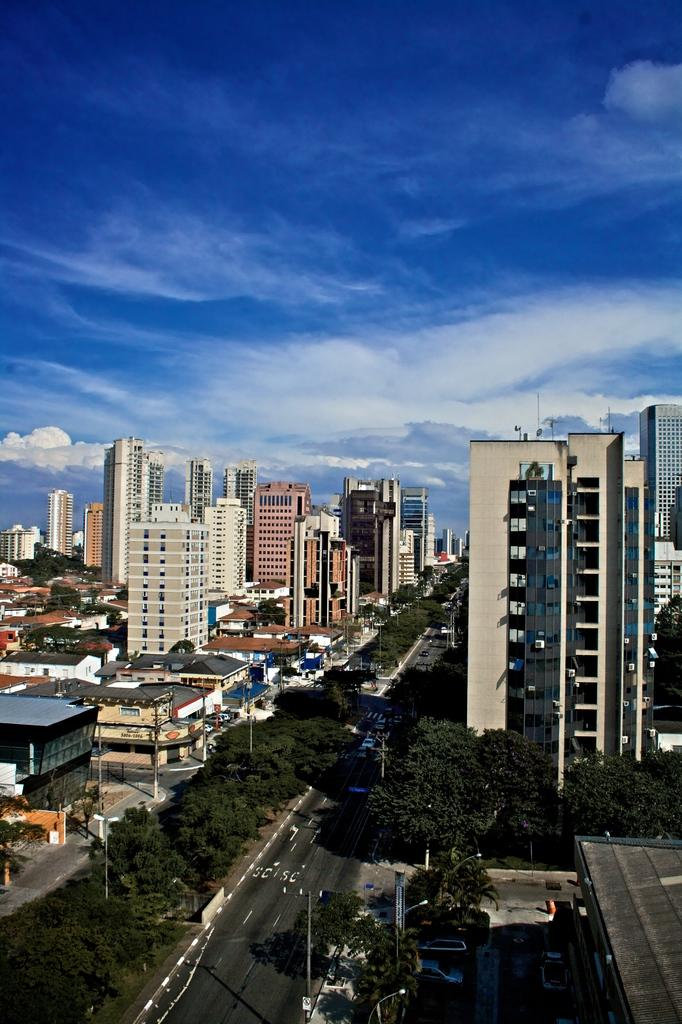What type of location is depicted in the image? The image shows a view of a city. What structures can be seen in the city? There are buildings and houses in the image. What mode of transportation might be using the roads in the image? Vehicles are visible in the image, which suggests that cars, buses, or other vehicles might be using the roads. What type of lighting is present in the image? Street lights are in the image. What type of vertical structures can be seen in the image? Poles are visible in the image. What type of natural elements are present in the image? Trees are present in the image. What part of the natural environment is visible in the image? The sky is visible in the image. What type of thread is being used to sew the point on the thumb in the image? There is no thread or thumb present in the image; it shows a view of a city with various elements such as buildings, houses, vehicles, roads, street lights, poles, trees, and the sky. 